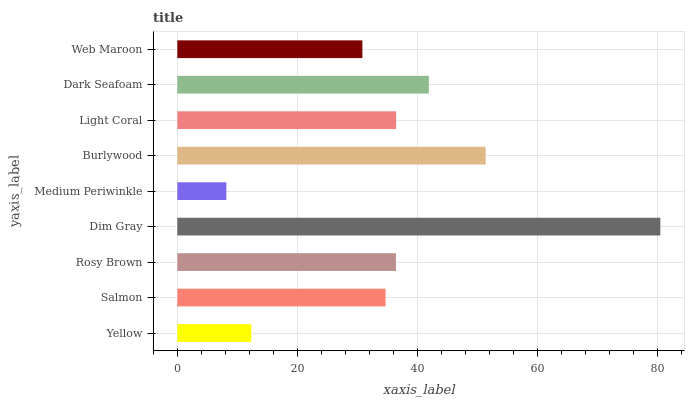Is Medium Periwinkle the minimum?
Answer yes or no. Yes. Is Dim Gray the maximum?
Answer yes or no. Yes. Is Salmon the minimum?
Answer yes or no. No. Is Salmon the maximum?
Answer yes or no. No. Is Salmon greater than Yellow?
Answer yes or no. Yes. Is Yellow less than Salmon?
Answer yes or no. Yes. Is Yellow greater than Salmon?
Answer yes or no. No. Is Salmon less than Yellow?
Answer yes or no. No. Is Rosy Brown the high median?
Answer yes or no. Yes. Is Rosy Brown the low median?
Answer yes or no. Yes. Is Salmon the high median?
Answer yes or no. No. Is Yellow the low median?
Answer yes or no. No. 